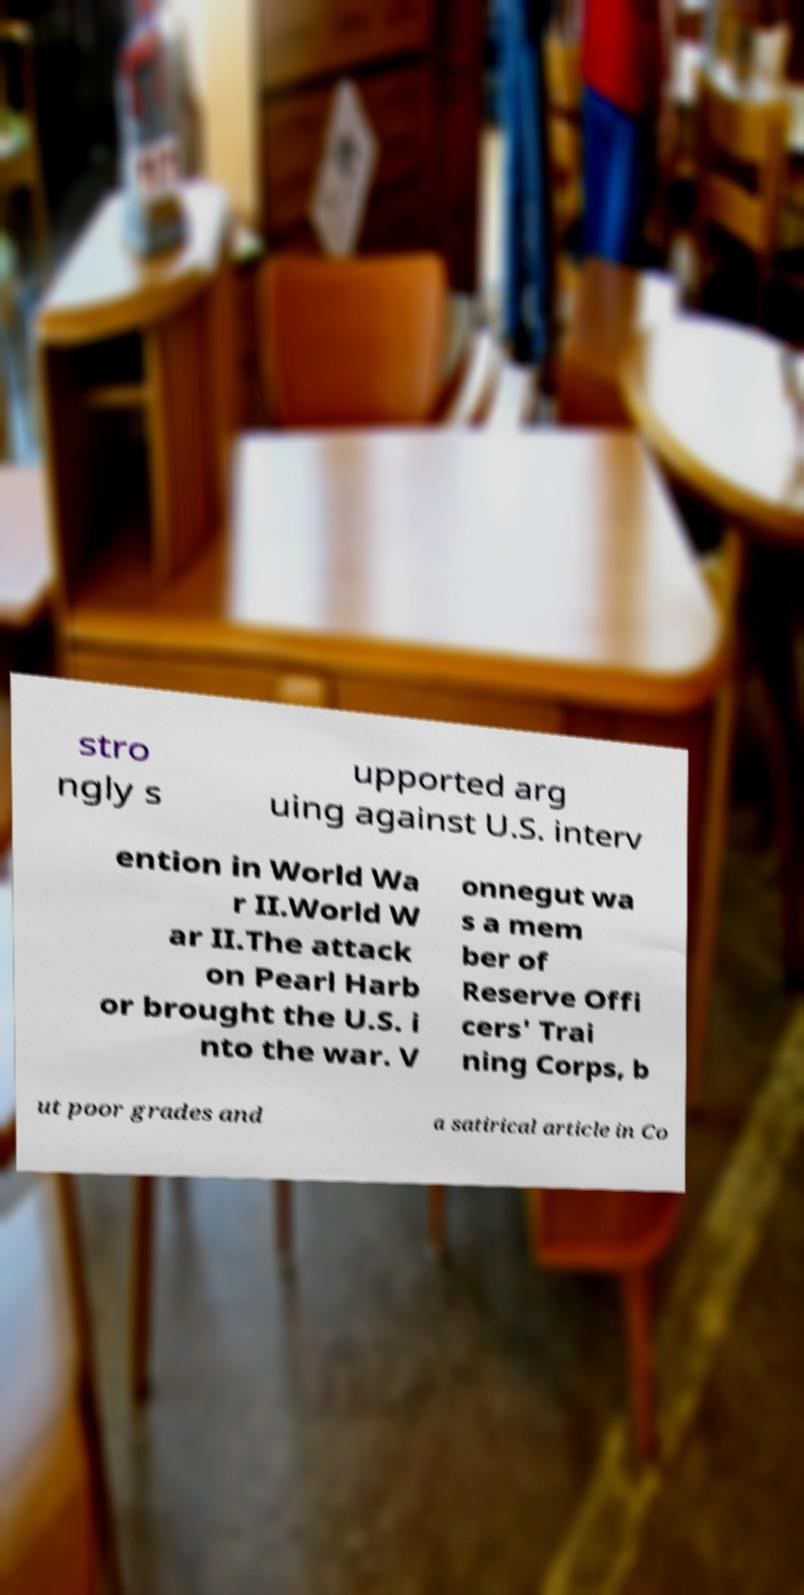Please identify and transcribe the text found in this image. stro ngly s upported arg uing against U.S. interv ention in World Wa r II.World W ar II.The attack on Pearl Harb or brought the U.S. i nto the war. V onnegut wa s a mem ber of Reserve Offi cers' Trai ning Corps, b ut poor grades and a satirical article in Co 